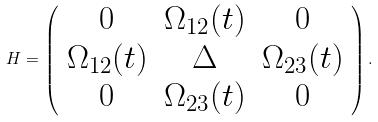<formula> <loc_0><loc_0><loc_500><loc_500>H = \left ( \begin{array} { c c c } 0 & \Omega _ { 1 2 } ( t ) & 0 \\ \Omega _ { 1 2 } ( t ) & \Delta & \Omega _ { 2 3 } ( t ) \\ 0 & \Omega _ { 2 3 } ( t ) & 0 \end{array} \right ) .</formula> 